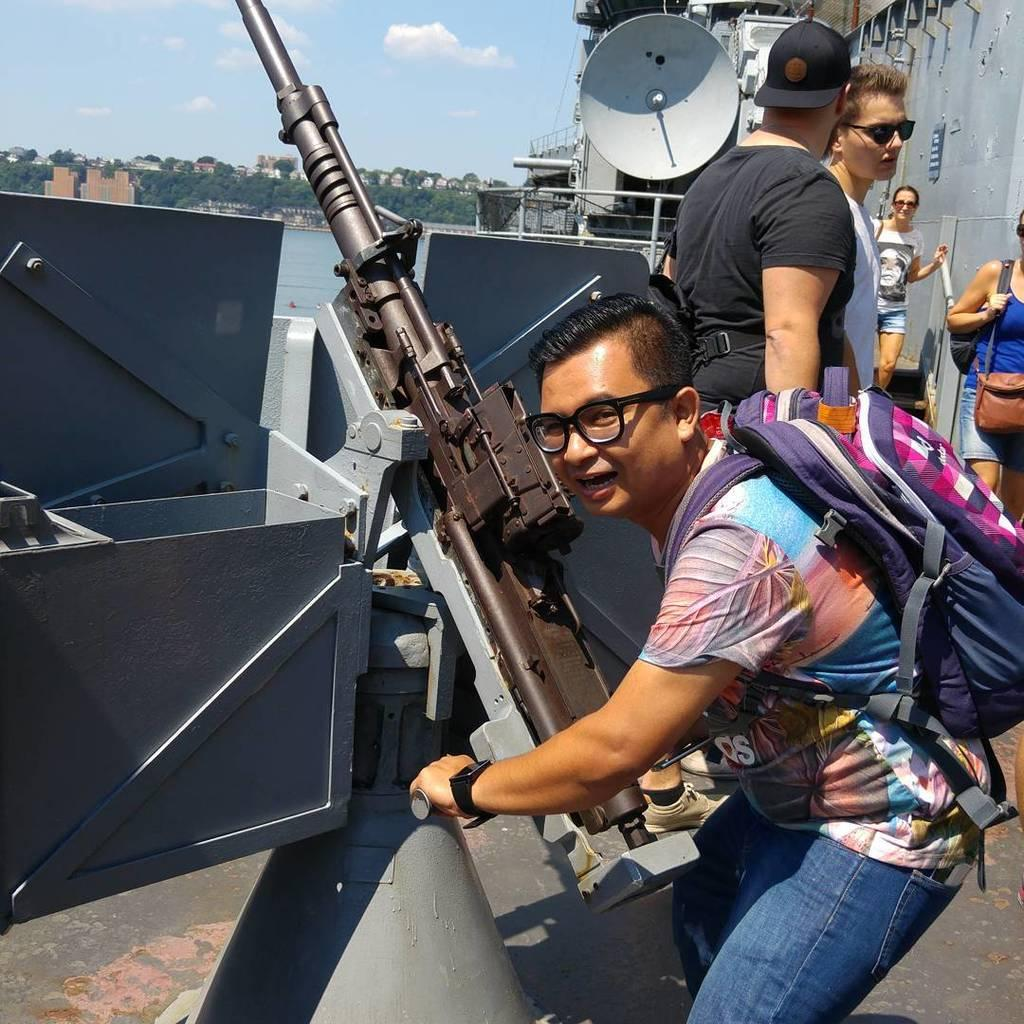What types of people are on the right side of the image? There are men and women on the right side of the image. What is one of the individuals doing in the image? One of them is holding an object. What can be seen in the background of the image? There are trees, buildings, and water visible in the background of the image. What is the color of the sky in the image? The sky is blue, and there are clouds visible. What book is the person reading in the image? There is no person reading a book in the image. What type of smell can be detected from the water in the image? There is no indication of any smell in the image, as it is a visual representation. 